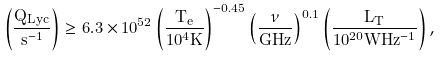Convert formula to latex. <formula><loc_0><loc_0><loc_500><loc_500>\left ( \frac { Q _ { L y c } } { s ^ { - 1 } } \right ) \geq 6 . 3 \times 1 0 ^ { 5 2 } \left ( \frac { T _ { e } } { 1 0 ^ { 4 } K } \right ) ^ { - 0 . 4 5 } \left ( \frac { \nu } { G H z } \right ) ^ { 0 . 1 } \left ( \frac { L _ { T } } { 1 0 ^ { 2 0 } W H z ^ { - 1 } } \right ) ,</formula> 